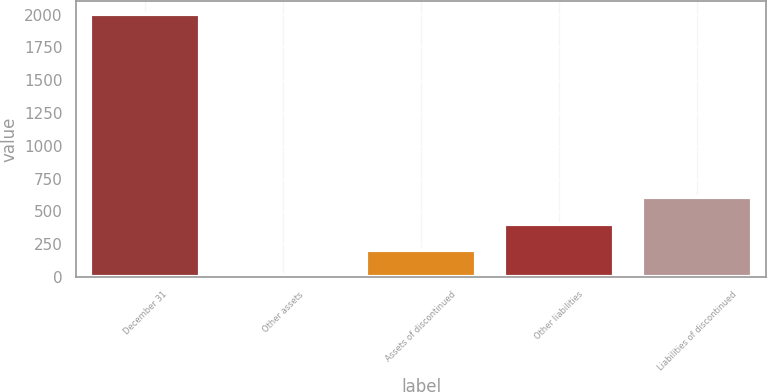Convert chart to OTSL. <chart><loc_0><loc_0><loc_500><loc_500><bar_chart><fcel>December 31<fcel>Other assets<fcel>Assets of discontinued<fcel>Other liabilities<fcel>Liabilities of discontinued<nl><fcel>2005<fcel>7<fcel>206.8<fcel>406.6<fcel>606.4<nl></chart> 